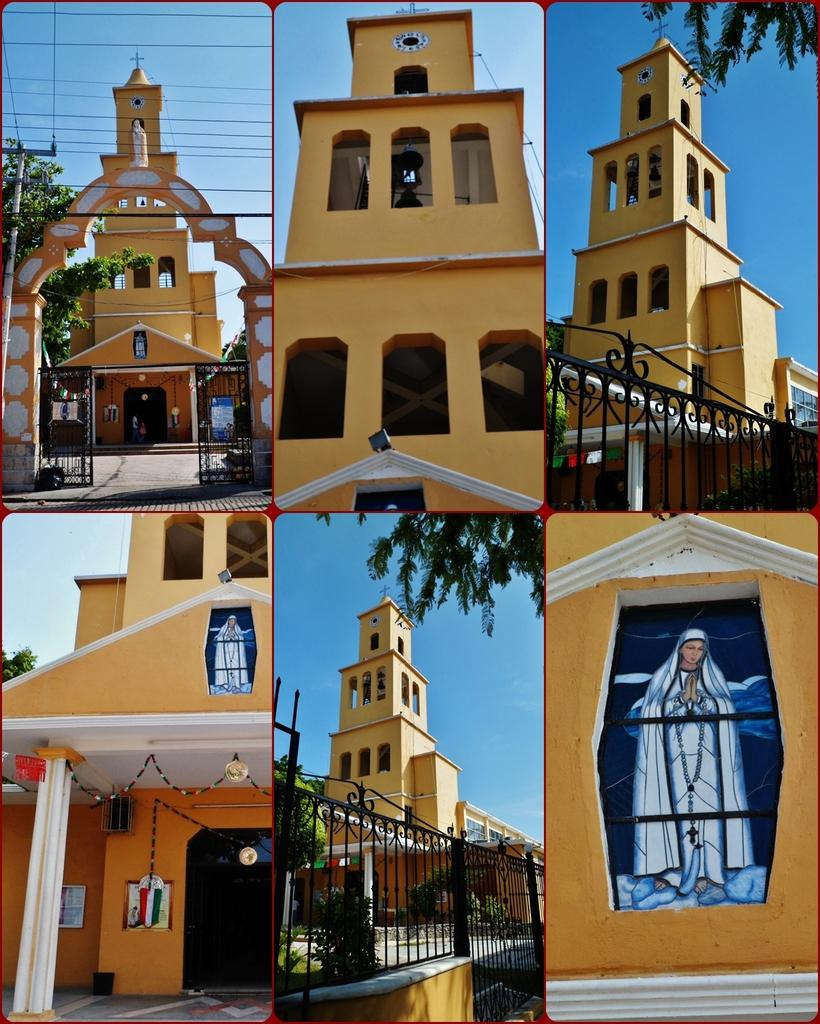What type of artwork is depicted in the image? The image is a collage. What subject matter is featured in the collage? Each part of the collage contains a different part of a church. How many kisses can be seen in the image? There are no kisses present in the image; it features a collage of different parts of a church. What type of transportation is depicted in the image? There is no transportation depicted in the image; it is a collage of different parts of a church. 